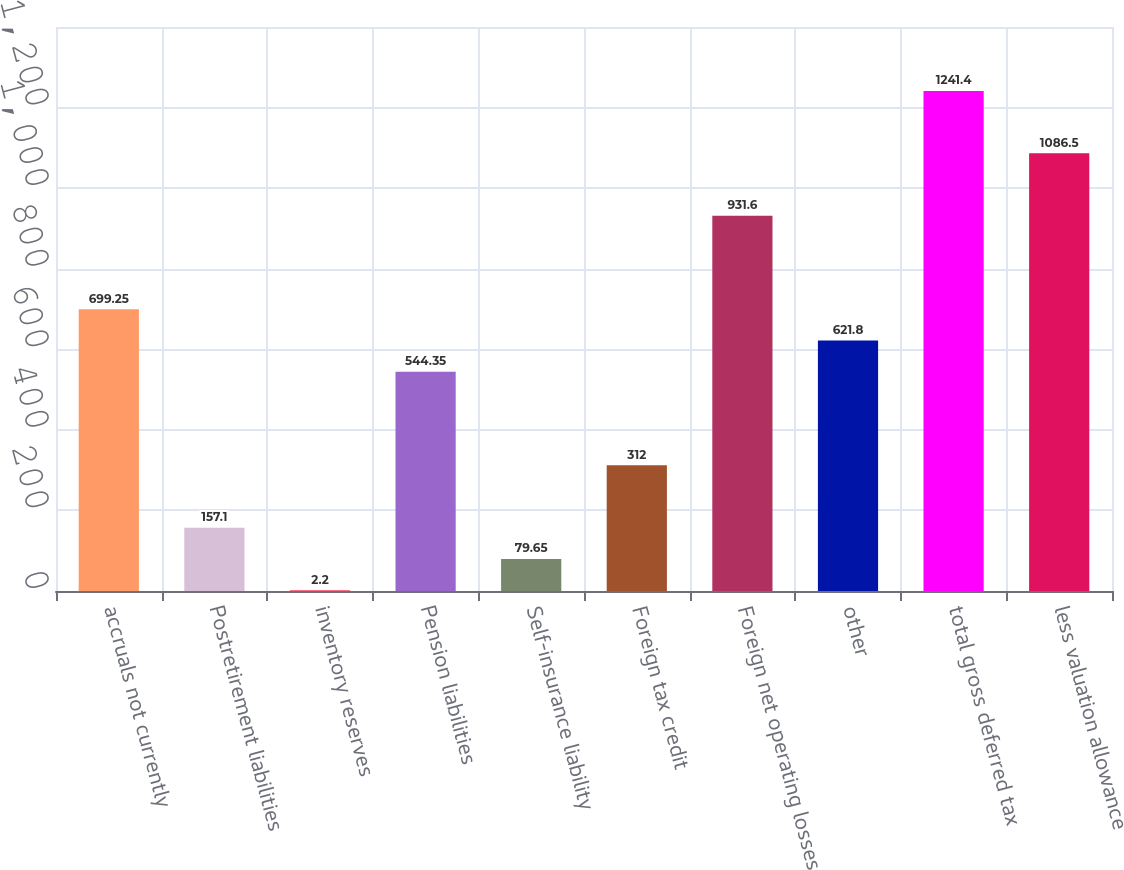<chart> <loc_0><loc_0><loc_500><loc_500><bar_chart><fcel>accruals not currently<fcel>Postretirement liabilities<fcel>inventory reserves<fcel>Pension liabilities<fcel>Self-insurance liability<fcel>Foreign tax credit<fcel>Foreign net operating losses<fcel>other<fcel>total gross deferred tax<fcel>less valuation allowance<nl><fcel>699.25<fcel>157.1<fcel>2.2<fcel>544.35<fcel>79.65<fcel>312<fcel>931.6<fcel>621.8<fcel>1241.4<fcel>1086.5<nl></chart> 